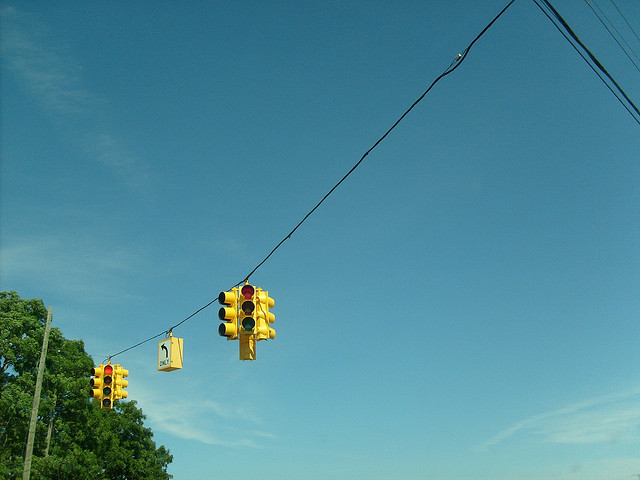How do these traffic lights influence pedestrian safety? These traffic lights likely include pedestrian signal phases, allowing people to cross safely while managing vehicle movements. This setup not only prioritizes vehicular flow but also ensures pedestrians can navigate intersections without conflict. Are there sensors on these lights to adjust their timings? Yes, modern traffic lights often include sensors that adjust timing based on traffic conditions. These sensors optimize light changes to minimize waiting times and reduce congestion, making traffic flow smoother for both vehicles and pedestrians. 